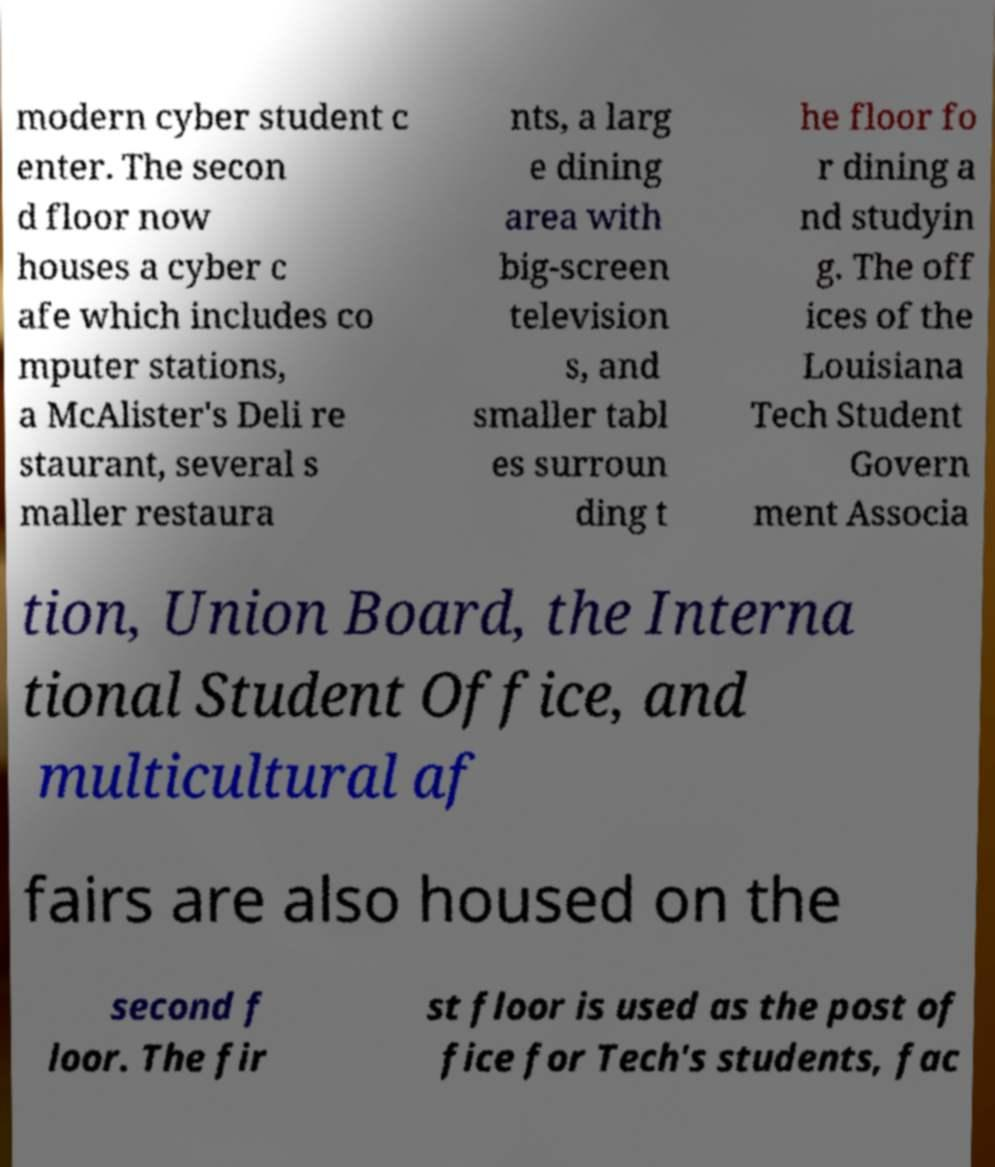Could you assist in decoding the text presented in this image and type it out clearly? modern cyber student c enter. The secon d floor now houses a cyber c afe which includes co mputer stations, a McAlister's Deli re staurant, several s maller restaura nts, a larg e dining area with big-screen television s, and smaller tabl es surroun ding t he floor fo r dining a nd studyin g. The off ices of the Louisiana Tech Student Govern ment Associa tion, Union Board, the Interna tional Student Office, and multicultural af fairs are also housed on the second f loor. The fir st floor is used as the post of fice for Tech's students, fac 